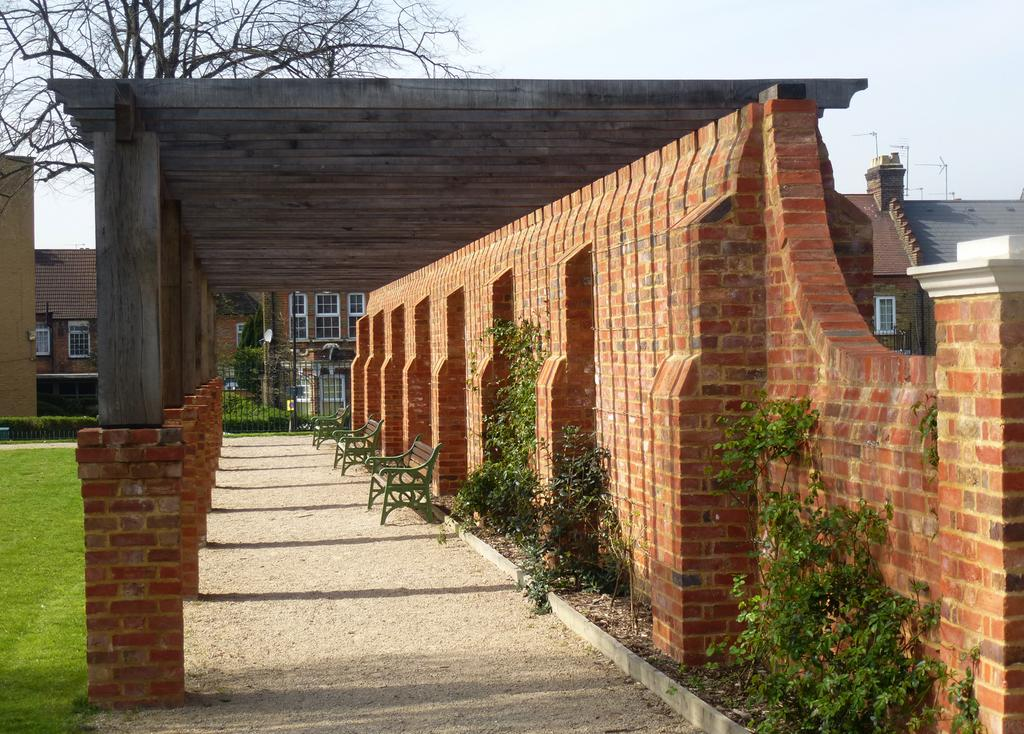What type of structure is present in the image? There is a shed in the image. What is on the shed? There are benches on the shed. What type of vegetation is visible in the image? There are plants in the image. What is the ground covered with in the image? There is grass visible in the image. What can be seen in the distance in the image? There are buildings in the background of the image. What type of rod is used to control the brake system in the image? There is no rod or brake system present in the image; it features a shed with benches, plants, grass, and buildings in the background. 